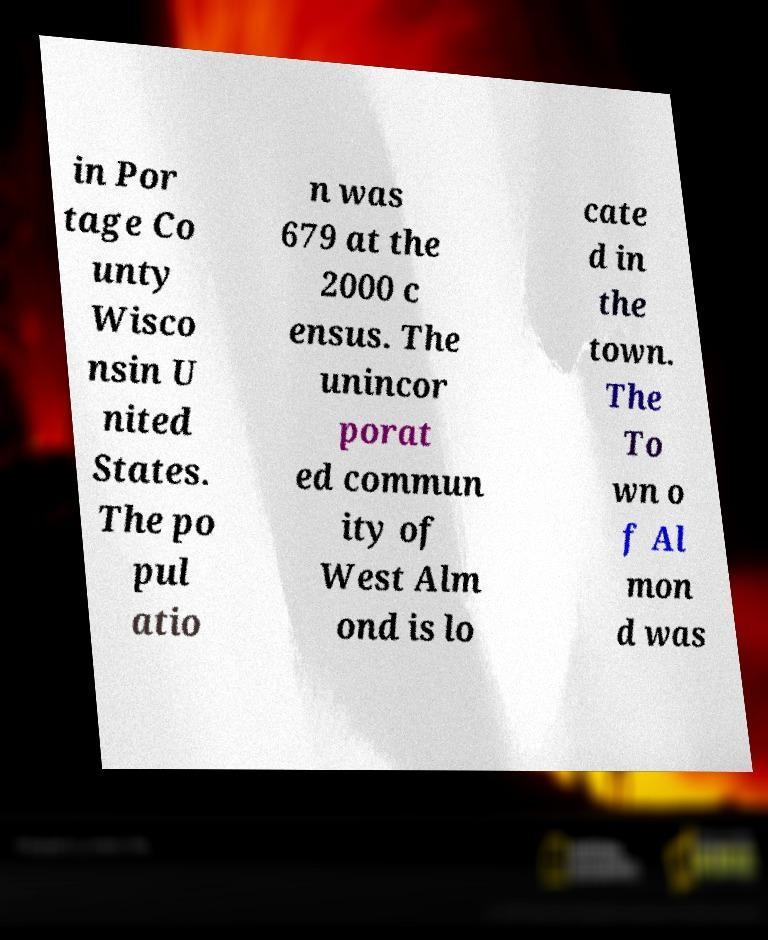Please identify and transcribe the text found in this image. in Por tage Co unty Wisco nsin U nited States. The po pul atio n was 679 at the 2000 c ensus. The unincor porat ed commun ity of West Alm ond is lo cate d in the town. The To wn o f Al mon d was 